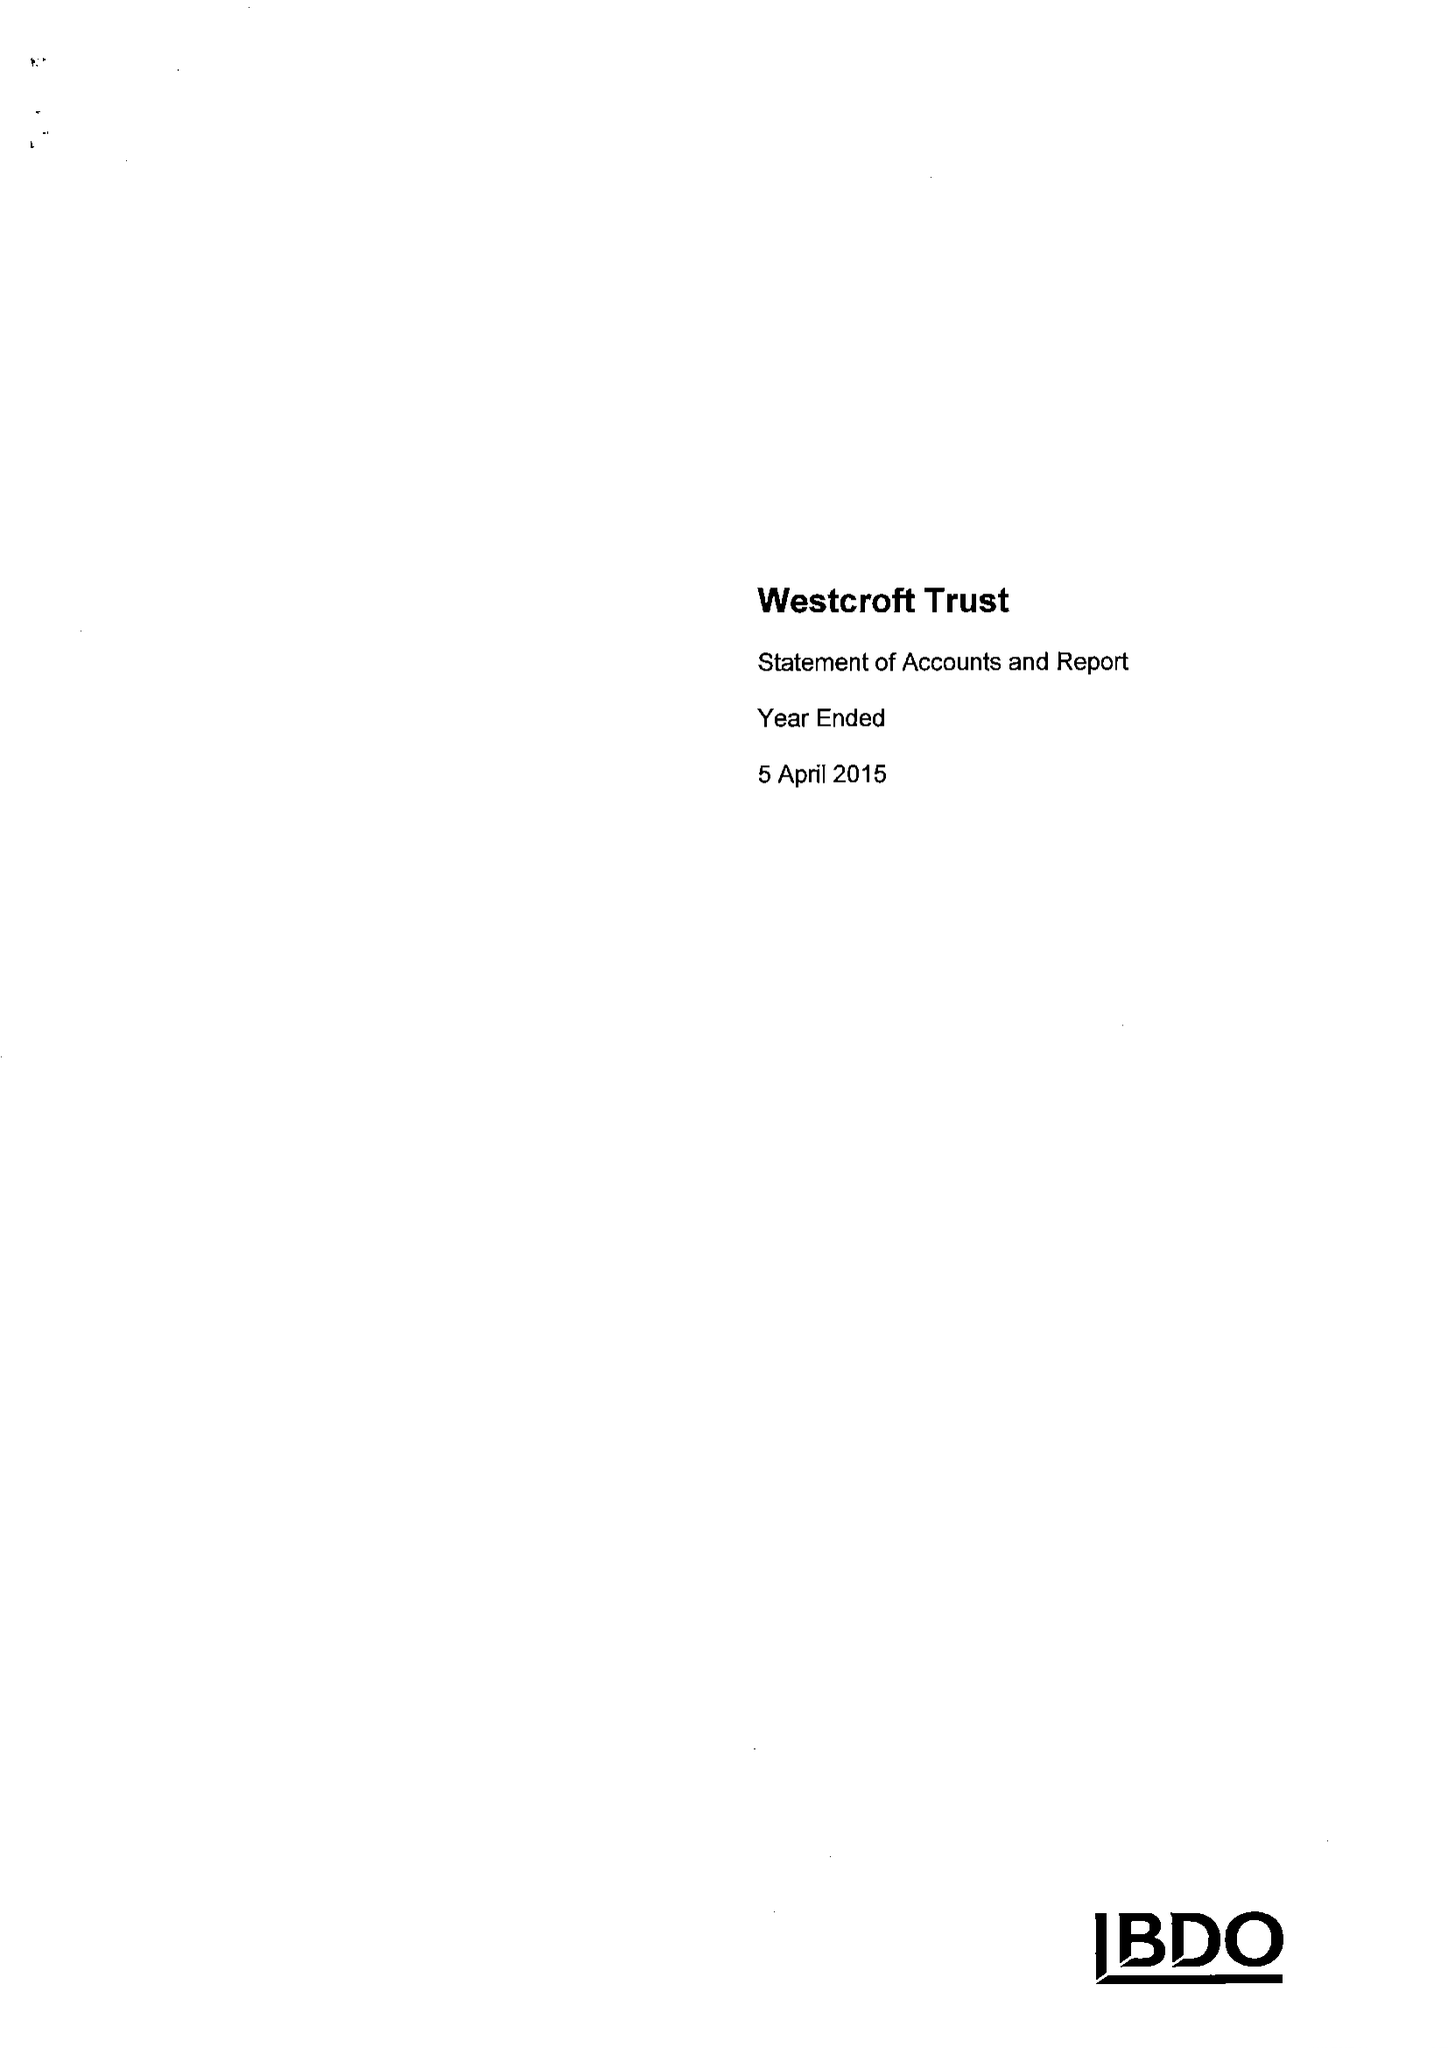What is the value for the income_annually_in_british_pounds?
Answer the question using a single word or phrase. 115404.00 